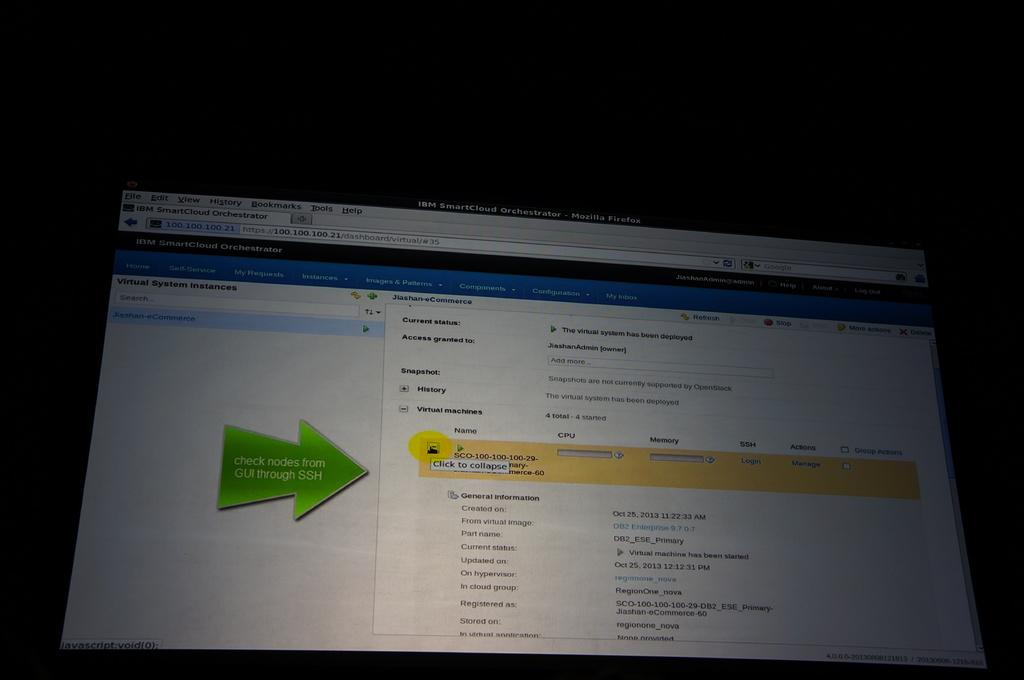<image>
Provide a brief description of the given image. A screen with a green arrow that says "Check Nodes from GUI through SSH" on it. 